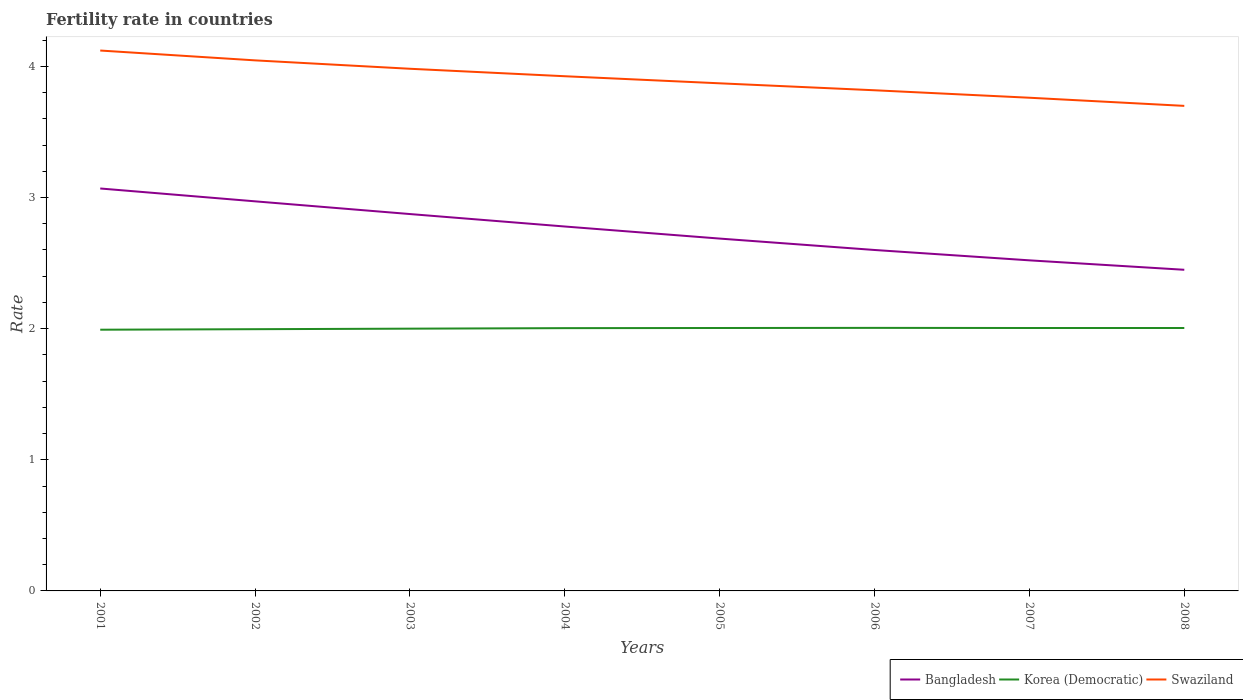Across all years, what is the maximum fertility rate in Bangladesh?
Offer a terse response. 2.45. In which year was the fertility rate in Bangladesh maximum?
Provide a short and direct response. 2008. What is the total fertility rate in Bangladesh in the graph?
Your answer should be very brief. 0.1. What is the difference between the highest and the second highest fertility rate in Swaziland?
Offer a very short reply. 0.42. Is the fertility rate in Korea (Democratic) strictly greater than the fertility rate in Swaziland over the years?
Offer a terse response. Yes. Where does the legend appear in the graph?
Your response must be concise. Bottom right. How many legend labels are there?
Keep it short and to the point. 3. How are the legend labels stacked?
Offer a very short reply. Horizontal. What is the title of the graph?
Provide a short and direct response. Fertility rate in countries. What is the label or title of the Y-axis?
Provide a succinct answer. Rate. What is the Rate of Bangladesh in 2001?
Give a very brief answer. 3.07. What is the Rate of Korea (Democratic) in 2001?
Your answer should be very brief. 1.99. What is the Rate in Swaziland in 2001?
Give a very brief answer. 4.12. What is the Rate of Bangladesh in 2002?
Ensure brevity in your answer.  2.97. What is the Rate of Korea (Democratic) in 2002?
Provide a short and direct response. 2. What is the Rate in Swaziland in 2002?
Keep it short and to the point. 4.05. What is the Rate of Bangladesh in 2003?
Your answer should be very brief. 2.87. What is the Rate of Korea (Democratic) in 2003?
Offer a terse response. 2. What is the Rate of Swaziland in 2003?
Offer a terse response. 3.98. What is the Rate of Bangladesh in 2004?
Offer a terse response. 2.78. What is the Rate of Korea (Democratic) in 2004?
Offer a terse response. 2. What is the Rate of Swaziland in 2004?
Give a very brief answer. 3.92. What is the Rate of Bangladesh in 2005?
Offer a very short reply. 2.69. What is the Rate in Korea (Democratic) in 2005?
Your answer should be compact. 2. What is the Rate of Swaziland in 2005?
Your answer should be very brief. 3.87. What is the Rate in Korea (Democratic) in 2006?
Make the answer very short. 2.01. What is the Rate in Swaziland in 2006?
Offer a terse response. 3.82. What is the Rate of Bangladesh in 2007?
Your answer should be compact. 2.52. What is the Rate of Korea (Democratic) in 2007?
Offer a terse response. 2. What is the Rate in Swaziland in 2007?
Your response must be concise. 3.76. What is the Rate in Bangladesh in 2008?
Give a very brief answer. 2.45. What is the Rate of Korea (Democratic) in 2008?
Your answer should be compact. 2. What is the Rate of Swaziland in 2008?
Ensure brevity in your answer.  3.7. Across all years, what is the maximum Rate of Bangladesh?
Offer a terse response. 3.07. Across all years, what is the maximum Rate of Korea (Democratic)?
Your answer should be compact. 2.01. Across all years, what is the maximum Rate in Swaziland?
Ensure brevity in your answer.  4.12. Across all years, what is the minimum Rate of Bangladesh?
Provide a short and direct response. 2.45. Across all years, what is the minimum Rate in Korea (Democratic)?
Your answer should be very brief. 1.99. Across all years, what is the minimum Rate of Swaziland?
Offer a terse response. 3.7. What is the total Rate of Bangladesh in the graph?
Provide a short and direct response. 21.95. What is the total Rate of Korea (Democratic) in the graph?
Ensure brevity in your answer.  16.01. What is the total Rate in Swaziland in the graph?
Your answer should be very brief. 31.22. What is the difference between the Rate of Bangladesh in 2001 and that in 2002?
Offer a terse response. 0.1. What is the difference between the Rate in Korea (Democratic) in 2001 and that in 2002?
Offer a very short reply. -0. What is the difference between the Rate in Swaziland in 2001 and that in 2002?
Give a very brief answer. 0.07. What is the difference between the Rate in Bangladesh in 2001 and that in 2003?
Offer a very short reply. 0.2. What is the difference between the Rate in Korea (Democratic) in 2001 and that in 2003?
Your answer should be compact. -0.01. What is the difference between the Rate of Swaziland in 2001 and that in 2003?
Ensure brevity in your answer.  0.14. What is the difference between the Rate of Bangladesh in 2001 and that in 2004?
Offer a very short reply. 0.29. What is the difference between the Rate in Korea (Democratic) in 2001 and that in 2004?
Your response must be concise. -0.01. What is the difference between the Rate of Swaziland in 2001 and that in 2004?
Your answer should be very brief. 0.2. What is the difference between the Rate in Bangladesh in 2001 and that in 2005?
Make the answer very short. 0.38. What is the difference between the Rate in Korea (Democratic) in 2001 and that in 2005?
Offer a terse response. -0.01. What is the difference between the Rate in Bangladesh in 2001 and that in 2006?
Provide a succinct answer. 0.47. What is the difference between the Rate in Korea (Democratic) in 2001 and that in 2006?
Give a very brief answer. -0.01. What is the difference between the Rate of Swaziland in 2001 and that in 2006?
Offer a very short reply. 0.3. What is the difference between the Rate of Bangladesh in 2001 and that in 2007?
Offer a very short reply. 0.55. What is the difference between the Rate of Korea (Democratic) in 2001 and that in 2007?
Your answer should be very brief. -0.01. What is the difference between the Rate in Swaziland in 2001 and that in 2007?
Ensure brevity in your answer.  0.36. What is the difference between the Rate in Bangladesh in 2001 and that in 2008?
Make the answer very short. 0.62. What is the difference between the Rate of Korea (Democratic) in 2001 and that in 2008?
Keep it short and to the point. -0.01. What is the difference between the Rate of Swaziland in 2001 and that in 2008?
Keep it short and to the point. 0.42. What is the difference between the Rate in Bangladesh in 2002 and that in 2003?
Provide a short and direct response. 0.1. What is the difference between the Rate in Korea (Democratic) in 2002 and that in 2003?
Offer a very short reply. -0. What is the difference between the Rate of Swaziland in 2002 and that in 2003?
Ensure brevity in your answer.  0.06. What is the difference between the Rate of Bangladesh in 2002 and that in 2004?
Your response must be concise. 0.19. What is the difference between the Rate of Korea (Democratic) in 2002 and that in 2004?
Give a very brief answer. -0.01. What is the difference between the Rate of Swaziland in 2002 and that in 2004?
Your answer should be very brief. 0.12. What is the difference between the Rate in Bangladesh in 2002 and that in 2005?
Your response must be concise. 0.28. What is the difference between the Rate of Korea (Democratic) in 2002 and that in 2005?
Your response must be concise. -0.01. What is the difference between the Rate in Swaziland in 2002 and that in 2005?
Provide a short and direct response. 0.17. What is the difference between the Rate in Bangladesh in 2002 and that in 2006?
Your answer should be compact. 0.37. What is the difference between the Rate of Korea (Democratic) in 2002 and that in 2006?
Provide a succinct answer. -0.01. What is the difference between the Rate in Swaziland in 2002 and that in 2006?
Provide a short and direct response. 0.23. What is the difference between the Rate of Bangladesh in 2002 and that in 2007?
Offer a very short reply. 0.45. What is the difference between the Rate of Korea (Democratic) in 2002 and that in 2007?
Offer a terse response. -0.01. What is the difference between the Rate in Swaziland in 2002 and that in 2007?
Ensure brevity in your answer.  0.28. What is the difference between the Rate of Bangladesh in 2002 and that in 2008?
Provide a short and direct response. 0.52. What is the difference between the Rate in Korea (Democratic) in 2002 and that in 2008?
Your answer should be compact. -0.01. What is the difference between the Rate of Swaziland in 2002 and that in 2008?
Offer a terse response. 0.35. What is the difference between the Rate in Bangladesh in 2003 and that in 2004?
Offer a very short reply. 0.1. What is the difference between the Rate of Korea (Democratic) in 2003 and that in 2004?
Keep it short and to the point. -0. What is the difference between the Rate in Swaziland in 2003 and that in 2004?
Provide a short and direct response. 0.06. What is the difference between the Rate in Bangladesh in 2003 and that in 2005?
Your answer should be very brief. 0.19. What is the difference between the Rate in Korea (Democratic) in 2003 and that in 2005?
Ensure brevity in your answer.  -0.01. What is the difference between the Rate of Swaziland in 2003 and that in 2005?
Your response must be concise. 0.11. What is the difference between the Rate in Bangladesh in 2003 and that in 2006?
Provide a short and direct response. 0.27. What is the difference between the Rate in Korea (Democratic) in 2003 and that in 2006?
Give a very brief answer. -0.01. What is the difference between the Rate of Swaziland in 2003 and that in 2006?
Your response must be concise. 0.16. What is the difference between the Rate in Bangladesh in 2003 and that in 2007?
Give a very brief answer. 0.35. What is the difference between the Rate in Korea (Democratic) in 2003 and that in 2007?
Your response must be concise. -0.01. What is the difference between the Rate of Swaziland in 2003 and that in 2007?
Your answer should be very brief. 0.22. What is the difference between the Rate in Bangladesh in 2003 and that in 2008?
Provide a succinct answer. 0.42. What is the difference between the Rate in Korea (Democratic) in 2003 and that in 2008?
Your answer should be very brief. -0.01. What is the difference between the Rate of Swaziland in 2003 and that in 2008?
Your response must be concise. 0.28. What is the difference between the Rate in Bangladesh in 2004 and that in 2005?
Your response must be concise. 0.09. What is the difference between the Rate of Korea (Democratic) in 2004 and that in 2005?
Provide a succinct answer. -0. What is the difference between the Rate of Swaziland in 2004 and that in 2005?
Make the answer very short. 0.05. What is the difference between the Rate of Bangladesh in 2004 and that in 2006?
Offer a terse response. 0.18. What is the difference between the Rate of Korea (Democratic) in 2004 and that in 2006?
Offer a very short reply. -0. What is the difference between the Rate in Swaziland in 2004 and that in 2006?
Give a very brief answer. 0.11. What is the difference between the Rate of Bangladesh in 2004 and that in 2007?
Offer a very short reply. 0.26. What is the difference between the Rate of Korea (Democratic) in 2004 and that in 2007?
Your answer should be compact. -0. What is the difference between the Rate in Swaziland in 2004 and that in 2007?
Your answer should be very brief. 0.16. What is the difference between the Rate of Bangladesh in 2004 and that in 2008?
Your answer should be compact. 0.33. What is the difference between the Rate of Korea (Democratic) in 2004 and that in 2008?
Give a very brief answer. -0. What is the difference between the Rate of Swaziland in 2004 and that in 2008?
Give a very brief answer. 0.23. What is the difference between the Rate of Bangladesh in 2005 and that in 2006?
Your answer should be very brief. 0.09. What is the difference between the Rate of Korea (Democratic) in 2005 and that in 2006?
Offer a terse response. -0. What is the difference between the Rate of Swaziland in 2005 and that in 2006?
Make the answer very short. 0.05. What is the difference between the Rate in Bangladesh in 2005 and that in 2007?
Provide a succinct answer. 0.17. What is the difference between the Rate in Swaziland in 2005 and that in 2007?
Give a very brief answer. 0.11. What is the difference between the Rate in Bangladesh in 2005 and that in 2008?
Offer a very short reply. 0.24. What is the difference between the Rate of Korea (Democratic) in 2005 and that in 2008?
Make the answer very short. 0. What is the difference between the Rate in Swaziland in 2005 and that in 2008?
Make the answer very short. 0.17. What is the difference between the Rate of Bangladesh in 2006 and that in 2007?
Give a very brief answer. 0.08. What is the difference between the Rate of Swaziland in 2006 and that in 2007?
Make the answer very short. 0.06. What is the difference between the Rate in Bangladesh in 2006 and that in 2008?
Provide a short and direct response. 0.15. What is the difference between the Rate of Swaziland in 2006 and that in 2008?
Your answer should be very brief. 0.12. What is the difference between the Rate of Bangladesh in 2007 and that in 2008?
Offer a very short reply. 0.07. What is the difference between the Rate of Korea (Democratic) in 2007 and that in 2008?
Ensure brevity in your answer.  0. What is the difference between the Rate of Swaziland in 2007 and that in 2008?
Your answer should be compact. 0.06. What is the difference between the Rate in Bangladesh in 2001 and the Rate in Korea (Democratic) in 2002?
Give a very brief answer. 1.07. What is the difference between the Rate in Bangladesh in 2001 and the Rate in Swaziland in 2002?
Your answer should be compact. -0.98. What is the difference between the Rate of Korea (Democratic) in 2001 and the Rate of Swaziland in 2002?
Your answer should be compact. -2.05. What is the difference between the Rate of Bangladesh in 2001 and the Rate of Korea (Democratic) in 2003?
Give a very brief answer. 1.07. What is the difference between the Rate of Bangladesh in 2001 and the Rate of Swaziland in 2003?
Your answer should be very brief. -0.91. What is the difference between the Rate of Korea (Democratic) in 2001 and the Rate of Swaziland in 2003?
Offer a terse response. -1.99. What is the difference between the Rate in Bangladesh in 2001 and the Rate in Korea (Democratic) in 2004?
Provide a succinct answer. 1.06. What is the difference between the Rate in Bangladesh in 2001 and the Rate in Swaziland in 2004?
Keep it short and to the point. -0.86. What is the difference between the Rate of Korea (Democratic) in 2001 and the Rate of Swaziland in 2004?
Your answer should be compact. -1.93. What is the difference between the Rate of Bangladesh in 2001 and the Rate of Korea (Democratic) in 2005?
Provide a succinct answer. 1.06. What is the difference between the Rate of Bangladesh in 2001 and the Rate of Swaziland in 2005?
Provide a short and direct response. -0.8. What is the difference between the Rate in Korea (Democratic) in 2001 and the Rate in Swaziland in 2005?
Provide a succinct answer. -1.88. What is the difference between the Rate in Bangladesh in 2001 and the Rate in Korea (Democratic) in 2006?
Ensure brevity in your answer.  1.06. What is the difference between the Rate in Bangladesh in 2001 and the Rate in Swaziland in 2006?
Your answer should be compact. -0.75. What is the difference between the Rate in Korea (Democratic) in 2001 and the Rate in Swaziland in 2006?
Keep it short and to the point. -1.83. What is the difference between the Rate of Bangladesh in 2001 and the Rate of Korea (Democratic) in 2007?
Give a very brief answer. 1.06. What is the difference between the Rate in Bangladesh in 2001 and the Rate in Swaziland in 2007?
Your answer should be compact. -0.69. What is the difference between the Rate in Korea (Democratic) in 2001 and the Rate in Swaziland in 2007?
Keep it short and to the point. -1.77. What is the difference between the Rate of Bangladesh in 2001 and the Rate of Korea (Democratic) in 2008?
Give a very brief answer. 1.06. What is the difference between the Rate of Bangladesh in 2001 and the Rate of Swaziland in 2008?
Offer a terse response. -0.63. What is the difference between the Rate of Korea (Democratic) in 2001 and the Rate of Swaziland in 2008?
Offer a terse response. -1.71. What is the difference between the Rate of Bangladesh in 2002 and the Rate of Korea (Democratic) in 2003?
Your answer should be compact. 0.97. What is the difference between the Rate in Bangladesh in 2002 and the Rate in Swaziland in 2003?
Keep it short and to the point. -1.01. What is the difference between the Rate in Korea (Democratic) in 2002 and the Rate in Swaziland in 2003?
Provide a succinct answer. -1.99. What is the difference between the Rate in Bangladesh in 2002 and the Rate in Swaziland in 2004?
Offer a very short reply. -0.95. What is the difference between the Rate of Korea (Democratic) in 2002 and the Rate of Swaziland in 2004?
Provide a succinct answer. -1.93. What is the difference between the Rate in Bangladesh in 2002 and the Rate in Korea (Democratic) in 2005?
Make the answer very short. 0.97. What is the difference between the Rate of Korea (Democratic) in 2002 and the Rate of Swaziland in 2005?
Your answer should be compact. -1.88. What is the difference between the Rate of Bangladesh in 2002 and the Rate of Swaziland in 2006?
Your answer should be compact. -0.85. What is the difference between the Rate in Korea (Democratic) in 2002 and the Rate in Swaziland in 2006?
Your answer should be very brief. -1.82. What is the difference between the Rate of Bangladesh in 2002 and the Rate of Swaziland in 2007?
Provide a short and direct response. -0.79. What is the difference between the Rate of Korea (Democratic) in 2002 and the Rate of Swaziland in 2007?
Offer a terse response. -1.76. What is the difference between the Rate in Bangladesh in 2002 and the Rate in Swaziland in 2008?
Your answer should be very brief. -0.73. What is the difference between the Rate of Korea (Democratic) in 2002 and the Rate of Swaziland in 2008?
Offer a very short reply. -1.7. What is the difference between the Rate of Bangladesh in 2003 and the Rate of Korea (Democratic) in 2004?
Provide a succinct answer. 0.87. What is the difference between the Rate of Bangladesh in 2003 and the Rate of Swaziland in 2004?
Offer a very short reply. -1.05. What is the difference between the Rate in Korea (Democratic) in 2003 and the Rate in Swaziland in 2004?
Provide a short and direct response. -1.93. What is the difference between the Rate of Bangladesh in 2003 and the Rate of Korea (Democratic) in 2005?
Your answer should be very brief. 0.87. What is the difference between the Rate in Bangladesh in 2003 and the Rate in Swaziland in 2005?
Provide a short and direct response. -1. What is the difference between the Rate of Korea (Democratic) in 2003 and the Rate of Swaziland in 2005?
Your answer should be compact. -1.87. What is the difference between the Rate in Bangladesh in 2003 and the Rate in Korea (Democratic) in 2006?
Ensure brevity in your answer.  0.87. What is the difference between the Rate of Bangladesh in 2003 and the Rate of Swaziland in 2006?
Your answer should be compact. -0.94. What is the difference between the Rate in Korea (Democratic) in 2003 and the Rate in Swaziland in 2006?
Make the answer very short. -1.82. What is the difference between the Rate in Bangladesh in 2003 and the Rate in Korea (Democratic) in 2007?
Offer a terse response. 0.87. What is the difference between the Rate of Bangladesh in 2003 and the Rate of Swaziland in 2007?
Ensure brevity in your answer.  -0.89. What is the difference between the Rate of Korea (Democratic) in 2003 and the Rate of Swaziland in 2007?
Offer a terse response. -1.76. What is the difference between the Rate in Bangladesh in 2003 and the Rate in Korea (Democratic) in 2008?
Make the answer very short. 0.87. What is the difference between the Rate of Bangladesh in 2003 and the Rate of Swaziland in 2008?
Offer a terse response. -0.82. What is the difference between the Rate in Korea (Democratic) in 2003 and the Rate in Swaziland in 2008?
Your answer should be compact. -1.7. What is the difference between the Rate of Bangladesh in 2004 and the Rate of Korea (Democratic) in 2005?
Your answer should be compact. 0.77. What is the difference between the Rate in Bangladesh in 2004 and the Rate in Swaziland in 2005?
Keep it short and to the point. -1.09. What is the difference between the Rate in Korea (Democratic) in 2004 and the Rate in Swaziland in 2005?
Offer a terse response. -1.87. What is the difference between the Rate in Bangladesh in 2004 and the Rate in Korea (Democratic) in 2006?
Offer a terse response. 0.77. What is the difference between the Rate in Bangladesh in 2004 and the Rate in Swaziland in 2006?
Make the answer very short. -1.04. What is the difference between the Rate in Korea (Democratic) in 2004 and the Rate in Swaziland in 2006?
Your response must be concise. -1.81. What is the difference between the Rate in Bangladesh in 2004 and the Rate in Korea (Democratic) in 2007?
Provide a succinct answer. 0.77. What is the difference between the Rate of Bangladesh in 2004 and the Rate of Swaziland in 2007?
Your response must be concise. -0.98. What is the difference between the Rate in Korea (Democratic) in 2004 and the Rate in Swaziland in 2007?
Provide a short and direct response. -1.76. What is the difference between the Rate of Bangladesh in 2004 and the Rate of Korea (Democratic) in 2008?
Make the answer very short. 0.77. What is the difference between the Rate of Bangladesh in 2004 and the Rate of Swaziland in 2008?
Offer a terse response. -0.92. What is the difference between the Rate in Korea (Democratic) in 2004 and the Rate in Swaziland in 2008?
Provide a succinct answer. -1.7. What is the difference between the Rate of Bangladesh in 2005 and the Rate of Korea (Democratic) in 2006?
Your response must be concise. 0.68. What is the difference between the Rate of Bangladesh in 2005 and the Rate of Swaziland in 2006?
Keep it short and to the point. -1.13. What is the difference between the Rate in Korea (Democratic) in 2005 and the Rate in Swaziland in 2006?
Make the answer very short. -1.81. What is the difference between the Rate of Bangladesh in 2005 and the Rate of Korea (Democratic) in 2007?
Offer a very short reply. 0.68. What is the difference between the Rate of Bangladesh in 2005 and the Rate of Swaziland in 2007?
Offer a terse response. -1.07. What is the difference between the Rate of Korea (Democratic) in 2005 and the Rate of Swaziland in 2007?
Provide a short and direct response. -1.76. What is the difference between the Rate of Bangladesh in 2005 and the Rate of Korea (Democratic) in 2008?
Provide a short and direct response. 0.68. What is the difference between the Rate in Bangladesh in 2005 and the Rate in Swaziland in 2008?
Offer a terse response. -1.01. What is the difference between the Rate in Korea (Democratic) in 2005 and the Rate in Swaziland in 2008?
Your answer should be very brief. -1.69. What is the difference between the Rate in Bangladesh in 2006 and the Rate in Korea (Democratic) in 2007?
Keep it short and to the point. 0.59. What is the difference between the Rate of Bangladesh in 2006 and the Rate of Swaziland in 2007?
Offer a very short reply. -1.16. What is the difference between the Rate of Korea (Democratic) in 2006 and the Rate of Swaziland in 2007?
Provide a short and direct response. -1.75. What is the difference between the Rate in Bangladesh in 2006 and the Rate in Korea (Democratic) in 2008?
Your answer should be compact. 0.59. What is the difference between the Rate in Bangladesh in 2006 and the Rate in Swaziland in 2008?
Provide a short and direct response. -1.1. What is the difference between the Rate of Korea (Democratic) in 2006 and the Rate of Swaziland in 2008?
Ensure brevity in your answer.  -1.69. What is the difference between the Rate in Bangladesh in 2007 and the Rate in Korea (Democratic) in 2008?
Your response must be concise. 0.52. What is the difference between the Rate of Bangladesh in 2007 and the Rate of Swaziland in 2008?
Offer a very short reply. -1.18. What is the difference between the Rate of Korea (Democratic) in 2007 and the Rate of Swaziland in 2008?
Offer a terse response. -1.69. What is the average Rate of Bangladesh per year?
Keep it short and to the point. 2.74. What is the average Rate in Korea (Democratic) per year?
Your response must be concise. 2. What is the average Rate in Swaziland per year?
Provide a short and direct response. 3.9. In the year 2001, what is the difference between the Rate in Bangladesh and Rate in Korea (Democratic)?
Your answer should be very brief. 1.08. In the year 2001, what is the difference between the Rate in Bangladesh and Rate in Swaziland?
Provide a succinct answer. -1.05. In the year 2001, what is the difference between the Rate of Korea (Democratic) and Rate of Swaziland?
Your answer should be compact. -2.13. In the year 2002, what is the difference between the Rate of Bangladesh and Rate of Swaziland?
Your answer should be very brief. -1.07. In the year 2002, what is the difference between the Rate of Korea (Democratic) and Rate of Swaziland?
Your answer should be compact. -2.05. In the year 2003, what is the difference between the Rate of Bangladesh and Rate of Korea (Democratic)?
Provide a succinct answer. 0.87. In the year 2003, what is the difference between the Rate in Bangladesh and Rate in Swaziland?
Make the answer very short. -1.11. In the year 2003, what is the difference between the Rate in Korea (Democratic) and Rate in Swaziland?
Your response must be concise. -1.98. In the year 2004, what is the difference between the Rate of Bangladesh and Rate of Korea (Democratic)?
Your answer should be compact. 0.78. In the year 2004, what is the difference between the Rate of Bangladesh and Rate of Swaziland?
Your answer should be very brief. -1.15. In the year 2004, what is the difference between the Rate in Korea (Democratic) and Rate in Swaziland?
Offer a terse response. -1.92. In the year 2005, what is the difference between the Rate of Bangladesh and Rate of Korea (Democratic)?
Your answer should be compact. 0.68. In the year 2005, what is the difference between the Rate of Bangladesh and Rate of Swaziland?
Your response must be concise. -1.18. In the year 2005, what is the difference between the Rate of Korea (Democratic) and Rate of Swaziland?
Your answer should be compact. -1.87. In the year 2006, what is the difference between the Rate of Bangladesh and Rate of Korea (Democratic)?
Provide a succinct answer. 0.59. In the year 2006, what is the difference between the Rate of Bangladesh and Rate of Swaziland?
Make the answer very short. -1.22. In the year 2006, what is the difference between the Rate in Korea (Democratic) and Rate in Swaziland?
Your answer should be very brief. -1.81. In the year 2007, what is the difference between the Rate in Bangladesh and Rate in Korea (Democratic)?
Your response must be concise. 0.52. In the year 2007, what is the difference between the Rate in Bangladesh and Rate in Swaziland?
Keep it short and to the point. -1.24. In the year 2007, what is the difference between the Rate of Korea (Democratic) and Rate of Swaziland?
Give a very brief answer. -1.76. In the year 2008, what is the difference between the Rate in Bangladesh and Rate in Korea (Democratic)?
Keep it short and to the point. 0.44. In the year 2008, what is the difference between the Rate in Bangladesh and Rate in Swaziland?
Ensure brevity in your answer.  -1.25. In the year 2008, what is the difference between the Rate in Korea (Democratic) and Rate in Swaziland?
Offer a terse response. -1.69. What is the ratio of the Rate in Bangladesh in 2001 to that in 2002?
Provide a succinct answer. 1.03. What is the ratio of the Rate in Swaziland in 2001 to that in 2002?
Offer a very short reply. 1.02. What is the ratio of the Rate of Bangladesh in 2001 to that in 2003?
Your answer should be compact. 1.07. What is the ratio of the Rate in Korea (Democratic) in 2001 to that in 2003?
Make the answer very short. 1. What is the ratio of the Rate of Swaziland in 2001 to that in 2003?
Provide a short and direct response. 1.03. What is the ratio of the Rate of Bangladesh in 2001 to that in 2004?
Offer a terse response. 1.1. What is the ratio of the Rate of Korea (Democratic) in 2001 to that in 2004?
Your answer should be compact. 0.99. What is the ratio of the Rate of Swaziland in 2001 to that in 2004?
Give a very brief answer. 1.05. What is the ratio of the Rate of Bangladesh in 2001 to that in 2005?
Provide a short and direct response. 1.14. What is the ratio of the Rate of Swaziland in 2001 to that in 2005?
Give a very brief answer. 1.06. What is the ratio of the Rate in Bangladesh in 2001 to that in 2006?
Make the answer very short. 1.18. What is the ratio of the Rate in Swaziland in 2001 to that in 2006?
Make the answer very short. 1.08. What is the ratio of the Rate of Bangladesh in 2001 to that in 2007?
Ensure brevity in your answer.  1.22. What is the ratio of the Rate in Swaziland in 2001 to that in 2007?
Make the answer very short. 1.1. What is the ratio of the Rate in Bangladesh in 2001 to that in 2008?
Your answer should be very brief. 1.25. What is the ratio of the Rate of Korea (Democratic) in 2001 to that in 2008?
Offer a very short reply. 0.99. What is the ratio of the Rate in Swaziland in 2001 to that in 2008?
Your answer should be compact. 1.11. What is the ratio of the Rate in Bangladesh in 2002 to that in 2003?
Keep it short and to the point. 1.03. What is the ratio of the Rate of Swaziland in 2002 to that in 2003?
Your answer should be very brief. 1.02. What is the ratio of the Rate in Bangladesh in 2002 to that in 2004?
Keep it short and to the point. 1.07. What is the ratio of the Rate of Swaziland in 2002 to that in 2004?
Offer a terse response. 1.03. What is the ratio of the Rate of Bangladesh in 2002 to that in 2005?
Offer a very short reply. 1.11. What is the ratio of the Rate of Swaziland in 2002 to that in 2005?
Keep it short and to the point. 1.05. What is the ratio of the Rate of Bangladesh in 2002 to that in 2006?
Your response must be concise. 1.14. What is the ratio of the Rate in Swaziland in 2002 to that in 2006?
Provide a succinct answer. 1.06. What is the ratio of the Rate in Bangladesh in 2002 to that in 2007?
Your answer should be very brief. 1.18. What is the ratio of the Rate in Swaziland in 2002 to that in 2007?
Ensure brevity in your answer.  1.08. What is the ratio of the Rate in Bangladesh in 2002 to that in 2008?
Your answer should be very brief. 1.21. What is the ratio of the Rate in Korea (Democratic) in 2002 to that in 2008?
Offer a terse response. 1. What is the ratio of the Rate in Swaziland in 2002 to that in 2008?
Keep it short and to the point. 1.09. What is the ratio of the Rate of Bangladesh in 2003 to that in 2004?
Offer a very short reply. 1.03. What is the ratio of the Rate of Korea (Democratic) in 2003 to that in 2004?
Offer a terse response. 1. What is the ratio of the Rate of Swaziland in 2003 to that in 2004?
Offer a very short reply. 1.01. What is the ratio of the Rate of Bangladesh in 2003 to that in 2005?
Offer a very short reply. 1.07. What is the ratio of the Rate of Korea (Democratic) in 2003 to that in 2005?
Keep it short and to the point. 1. What is the ratio of the Rate in Swaziland in 2003 to that in 2005?
Your answer should be compact. 1.03. What is the ratio of the Rate of Bangladesh in 2003 to that in 2006?
Ensure brevity in your answer.  1.11. What is the ratio of the Rate in Korea (Democratic) in 2003 to that in 2006?
Offer a terse response. 1. What is the ratio of the Rate of Swaziland in 2003 to that in 2006?
Provide a succinct answer. 1.04. What is the ratio of the Rate of Bangladesh in 2003 to that in 2007?
Your answer should be compact. 1.14. What is the ratio of the Rate of Korea (Democratic) in 2003 to that in 2007?
Make the answer very short. 1. What is the ratio of the Rate of Swaziland in 2003 to that in 2007?
Your answer should be compact. 1.06. What is the ratio of the Rate in Bangladesh in 2003 to that in 2008?
Provide a short and direct response. 1.17. What is the ratio of the Rate in Korea (Democratic) in 2003 to that in 2008?
Give a very brief answer. 1. What is the ratio of the Rate in Swaziland in 2003 to that in 2008?
Offer a terse response. 1.08. What is the ratio of the Rate in Bangladesh in 2004 to that in 2005?
Make the answer very short. 1.03. What is the ratio of the Rate in Swaziland in 2004 to that in 2005?
Give a very brief answer. 1.01. What is the ratio of the Rate in Bangladesh in 2004 to that in 2006?
Make the answer very short. 1.07. What is the ratio of the Rate of Swaziland in 2004 to that in 2006?
Give a very brief answer. 1.03. What is the ratio of the Rate of Bangladesh in 2004 to that in 2007?
Provide a short and direct response. 1.1. What is the ratio of the Rate of Swaziland in 2004 to that in 2007?
Keep it short and to the point. 1.04. What is the ratio of the Rate in Bangladesh in 2004 to that in 2008?
Your response must be concise. 1.13. What is the ratio of the Rate of Swaziland in 2004 to that in 2008?
Offer a very short reply. 1.06. What is the ratio of the Rate in Bangladesh in 2005 to that in 2006?
Offer a very short reply. 1.03. What is the ratio of the Rate in Korea (Democratic) in 2005 to that in 2006?
Provide a short and direct response. 1. What is the ratio of the Rate in Swaziland in 2005 to that in 2006?
Provide a succinct answer. 1.01. What is the ratio of the Rate in Bangladesh in 2005 to that in 2007?
Give a very brief answer. 1.07. What is the ratio of the Rate of Swaziland in 2005 to that in 2007?
Provide a succinct answer. 1.03. What is the ratio of the Rate of Bangladesh in 2005 to that in 2008?
Make the answer very short. 1.1. What is the ratio of the Rate in Korea (Democratic) in 2005 to that in 2008?
Your answer should be very brief. 1. What is the ratio of the Rate in Swaziland in 2005 to that in 2008?
Offer a terse response. 1.05. What is the ratio of the Rate in Bangladesh in 2006 to that in 2007?
Give a very brief answer. 1.03. What is the ratio of the Rate of Korea (Democratic) in 2006 to that in 2007?
Provide a short and direct response. 1. What is the ratio of the Rate of Swaziland in 2006 to that in 2007?
Your answer should be compact. 1.02. What is the ratio of the Rate of Bangladesh in 2006 to that in 2008?
Provide a succinct answer. 1.06. What is the ratio of the Rate in Swaziland in 2006 to that in 2008?
Ensure brevity in your answer.  1.03. What is the ratio of the Rate in Bangladesh in 2007 to that in 2008?
Your response must be concise. 1.03. What is the ratio of the Rate of Korea (Democratic) in 2007 to that in 2008?
Your answer should be compact. 1. What is the ratio of the Rate of Swaziland in 2007 to that in 2008?
Your answer should be compact. 1.02. What is the difference between the highest and the second highest Rate of Bangladesh?
Your answer should be very brief. 0.1. What is the difference between the highest and the second highest Rate of Korea (Democratic)?
Provide a short and direct response. 0. What is the difference between the highest and the second highest Rate in Swaziland?
Make the answer very short. 0.07. What is the difference between the highest and the lowest Rate in Bangladesh?
Your answer should be very brief. 0.62. What is the difference between the highest and the lowest Rate of Korea (Democratic)?
Your answer should be very brief. 0.01. What is the difference between the highest and the lowest Rate of Swaziland?
Your response must be concise. 0.42. 